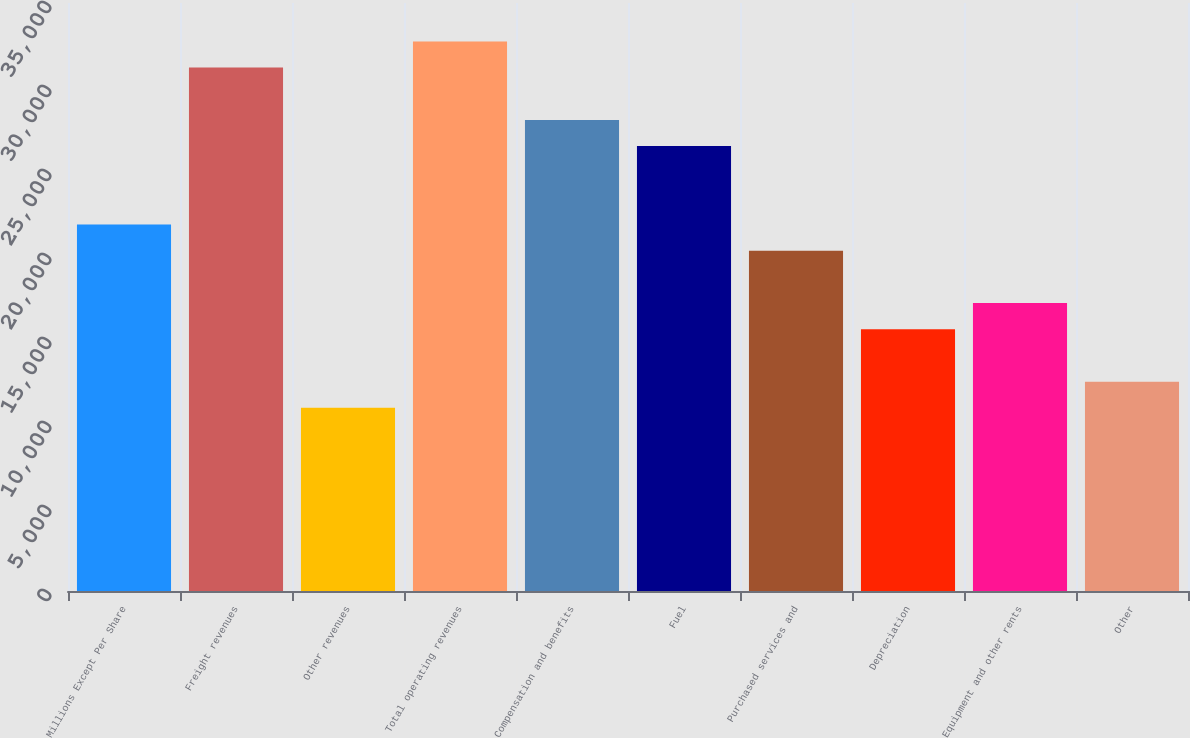Convert chart to OTSL. <chart><loc_0><loc_0><loc_500><loc_500><bar_chart><fcel>Millions Except Per Share<fcel>Freight revenues<fcel>Other revenues<fcel>Total operating revenues<fcel>Compensation and benefits<fcel>Fuel<fcel>Purchased services and<fcel>Depreciation<fcel>Equipment and other rents<fcel>Other<nl><fcel>21809<fcel>31155.4<fcel>10904.8<fcel>32713.1<fcel>28039.9<fcel>26482.2<fcel>20251.2<fcel>15578<fcel>17135.7<fcel>12462.5<nl></chart> 